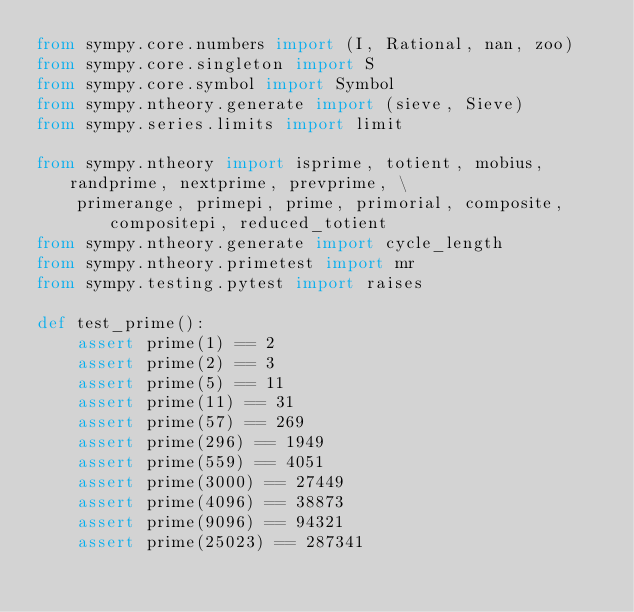Convert code to text. <code><loc_0><loc_0><loc_500><loc_500><_Python_>from sympy.core.numbers import (I, Rational, nan, zoo)
from sympy.core.singleton import S
from sympy.core.symbol import Symbol
from sympy.ntheory.generate import (sieve, Sieve)
from sympy.series.limits import limit

from sympy.ntheory import isprime, totient, mobius, randprime, nextprime, prevprime, \
    primerange, primepi, prime, primorial, composite, compositepi, reduced_totient
from sympy.ntheory.generate import cycle_length
from sympy.ntheory.primetest import mr
from sympy.testing.pytest import raises

def test_prime():
    assert prime(1) == 2
    assert prime(2) == 3
    assert prime(5) == 11
    assert prime(11) == 31
    assert prime(57) == 269
    assert prime(296) == 1949
    assert prime(559) == 4051
    assert prime(3000) == 27449
    assert prime(4096) == 38873
    assert prime(9096) == 94321
    assert prime(25023) == 287341</code> 